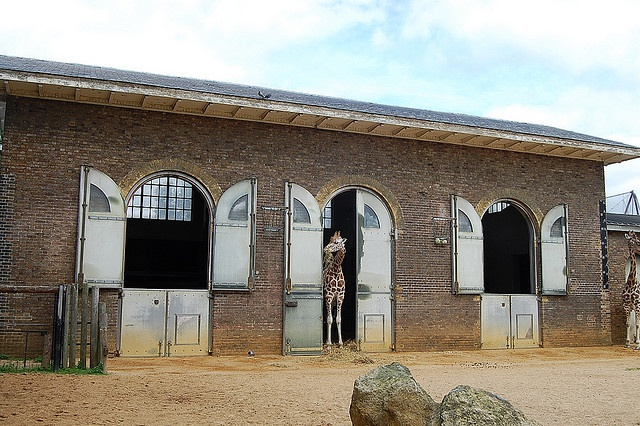Describe the objects in this image and their specific colors. I can see giraffe in white, black, gray, darkgray, and lightgray tones and giraffe in white, black, gray, darkgray, and maroon tones in this image. 